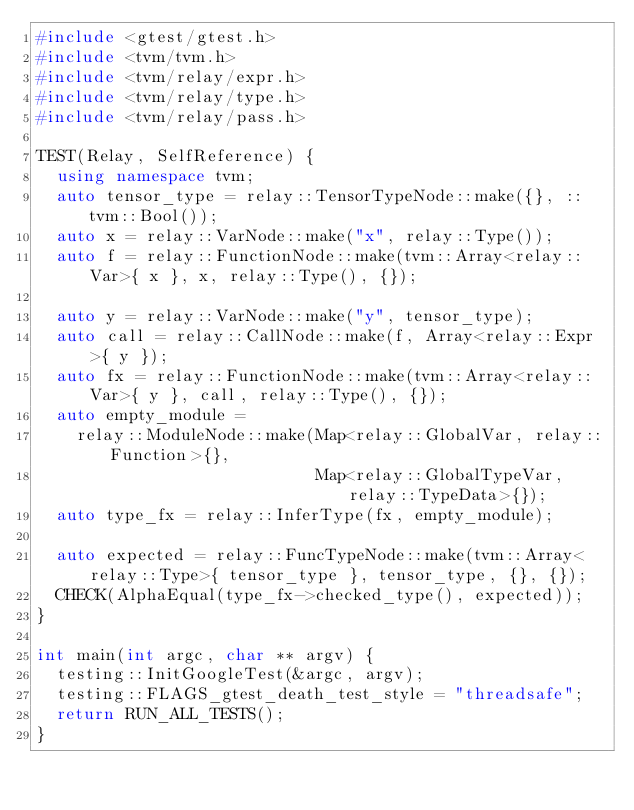<code> <loc_0><loc_0><loc_500><loc_500><_C++_>#include <gtest/gtest.h>
#include <tvm/tvm.h>
#include <tvm/relay/expr.h>
#include <tvm/relay/type.h>
#include <tvm/relay/pass.h>

TEST(Relay, SelfReference) {
  using namespace tvm;
  auto tensor_type = relay::TensorTypeNode::make({}, ::tvm::Bool());
  auto x = relay::VarNode::make("x", relay::Type());
  auto f = relay::FunctionNode::make(tvm::Array<relay::Var>{ x }, x, relay::Type(), {});

  auto y = relay::VarNode::make("y", tensor_type);
  auto call = relay::CallNode::make(f, Array<relay::Expr>{ y });
  auto fx = relay::FunctionNode::make(tvm::Array<relay::Var>{ y }, call, relay::Type(), {});
  auto empty_module =
    relay::ModuleNode::make(Map<relay::GlobalVar, relay::Function>{},
                            Map<relay::GlobalTypeVar, relay::TypeData>{});
  auto type_fx = relay::InferType(fx, empty_module);

  auto expected = relay::FuncTypeNode::make(tvm::Array<relay::Type>{ tensor_type }, tensor_type, {}, {});
  CHECK(AlphaEqual(type_fx->checked_type(), expected));
}

int main(int argc, char ** argv) {
  testing::InitGoogleTest(&argc, argv);
  testing::FLAGS_gtest_death_test_style = "threadsafe";
  return RUN_ALL_TESTS();
}
</code> 